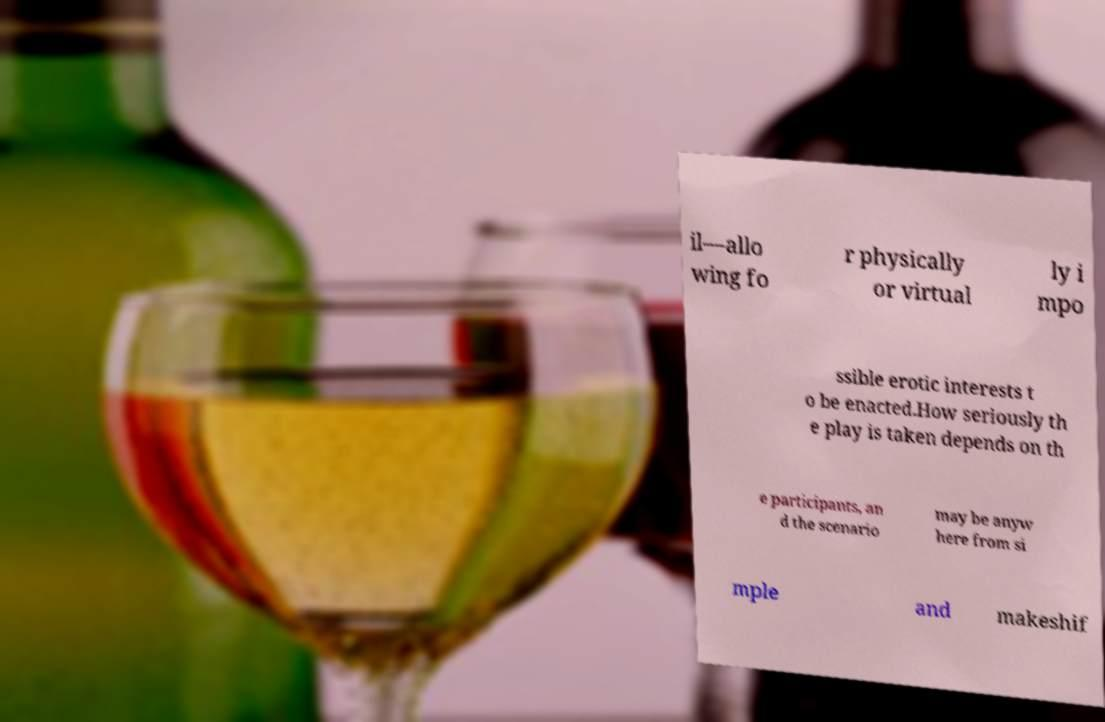What messages or text are displayed in this image? I need them in a readable, typed format. il—allo wing fo r physically or virtual ly i mpo ssible erotic interests t o be enacted.How seriously th e play is taken depends on th e participants, an d the scenario may be anyw here from si mple and makeshif 